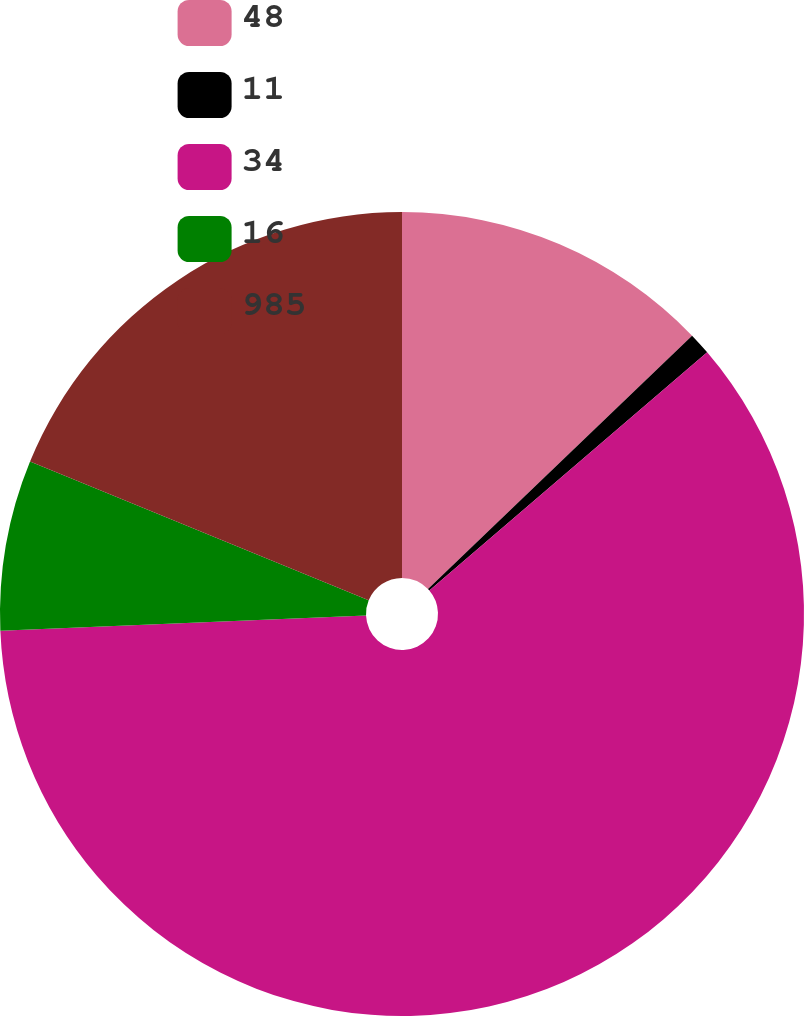<chart> <loc_0><loc_0><loc_500><loc_500><pie_chart><fcel>48<fcel>11<fcel>34<fcel>16<fcel>985<nl><fcel>12.83%<fcel>0.89%<fcel>60.62%<fcel>6.86%<fcel>18.81%<nl></chart> 